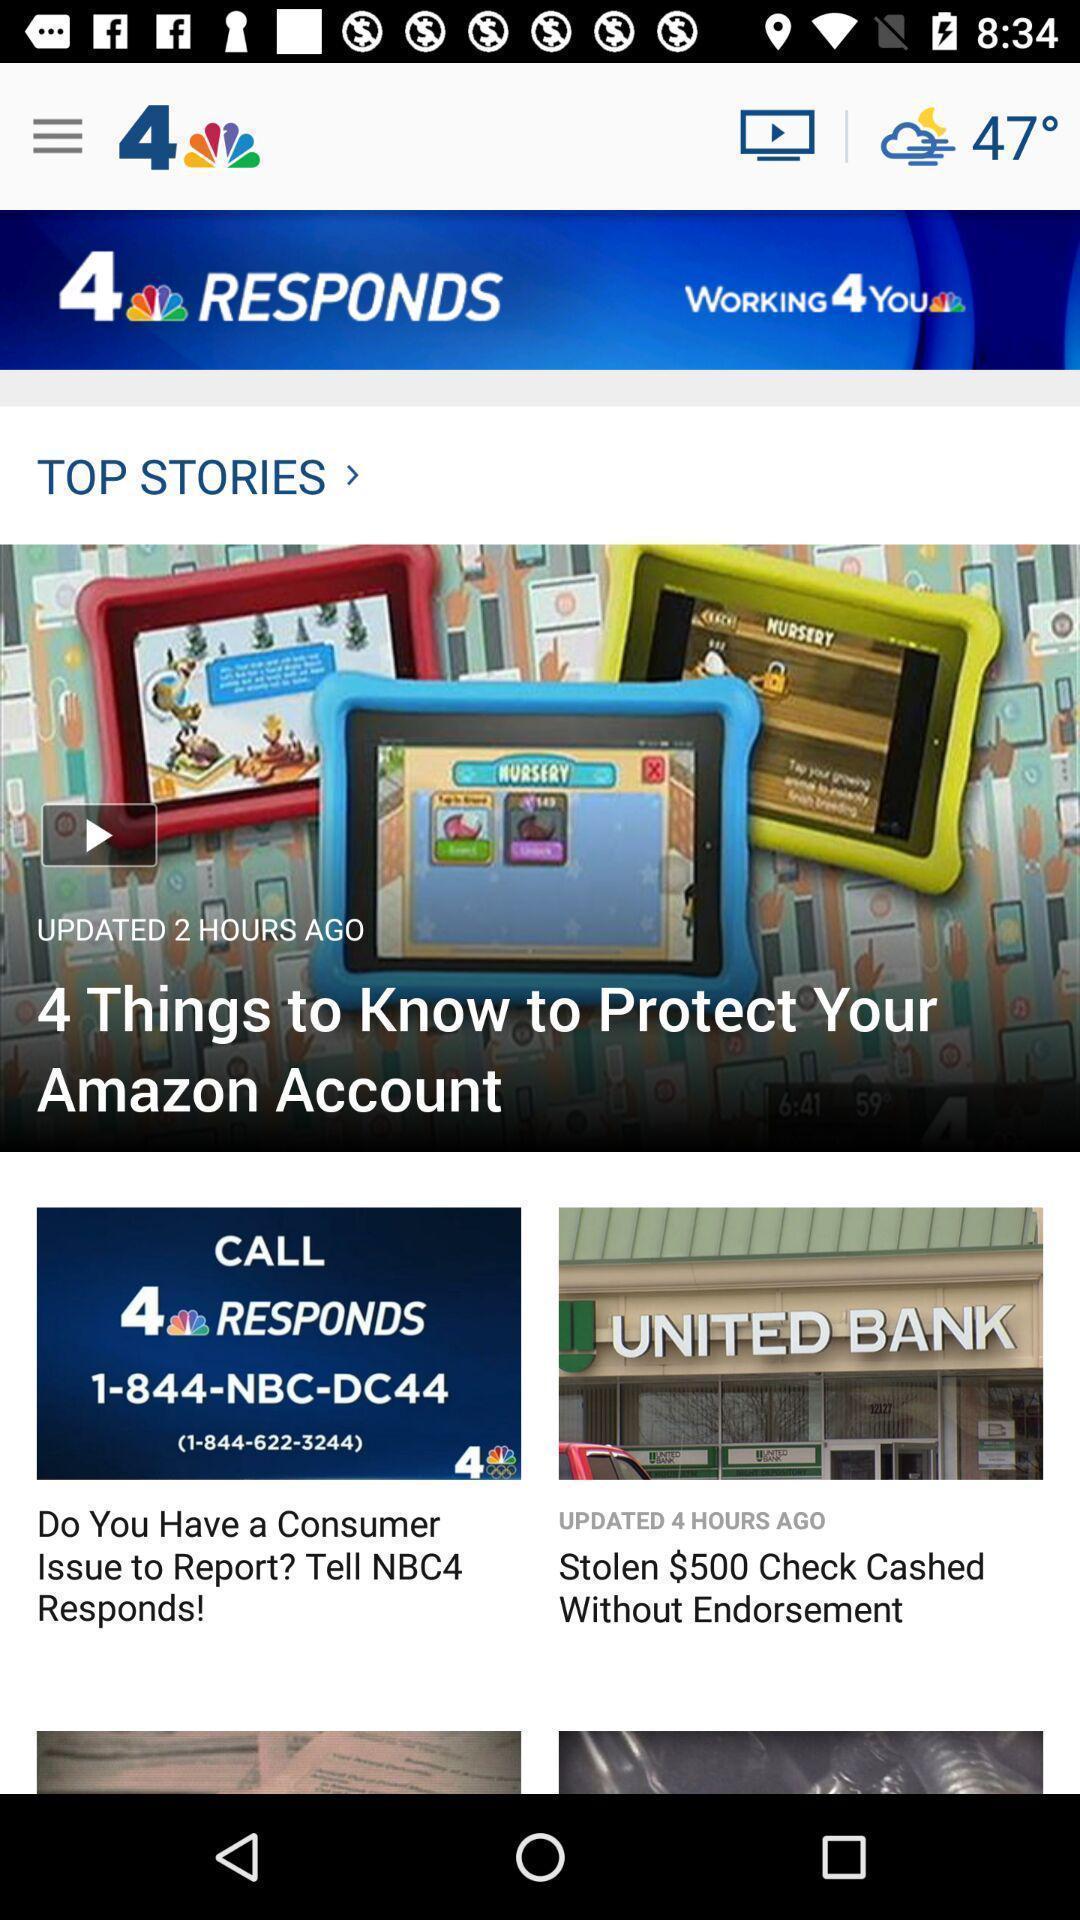Tell me about the visual elements in this screen capture. Page of a news app showing stories. 